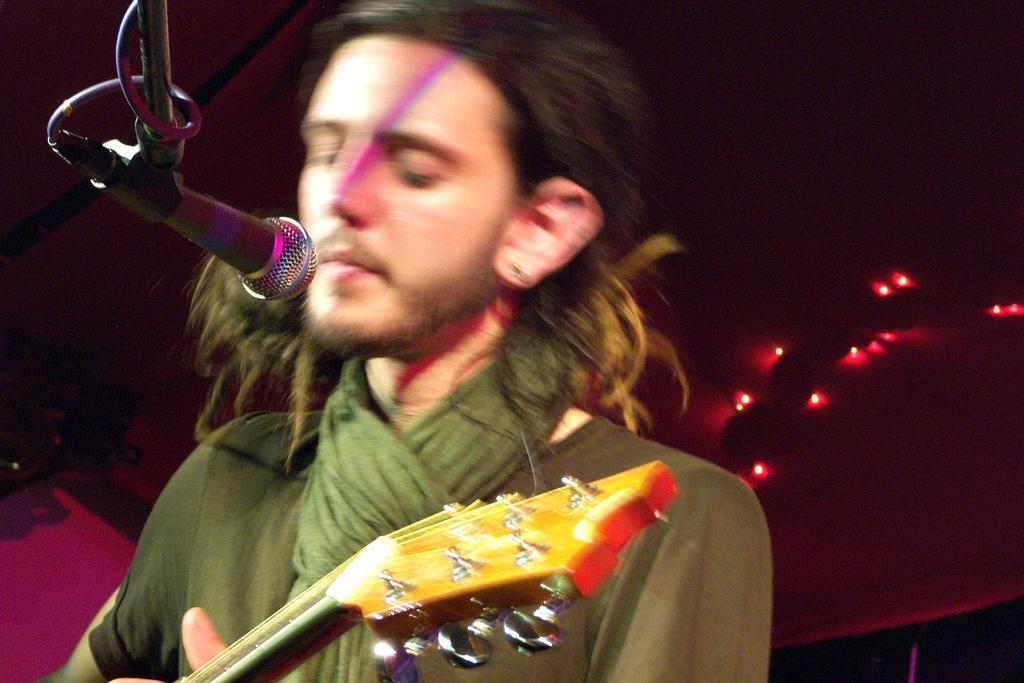Describe this image in one or two sentences. In this image in front there is a person holding the mike. In front of him there is a mike. Behind him there are lights. 